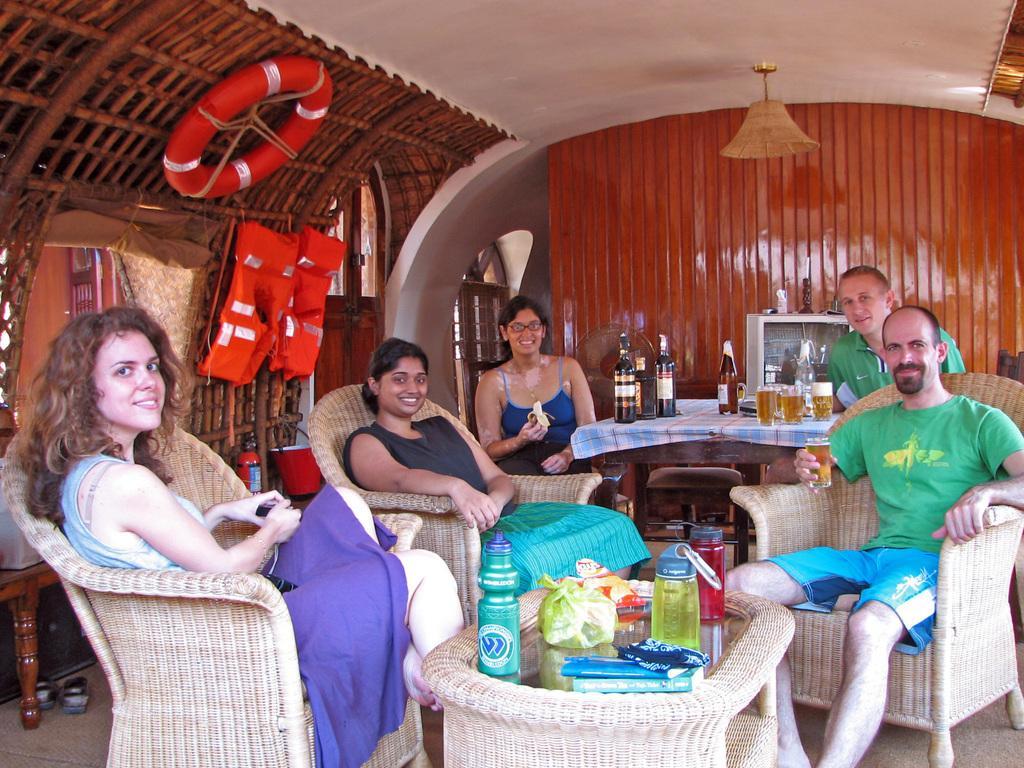Describe this image in one or two sentences. In this image there are a group of people sitting on chairs, and at the bottom of the image there is one table. On the table there are some bottles and some plastic covers, and in the background there is another table. On the table there are some bottles, glasses and there is one television. On the television there are some toys, and at the top there is ceiling and one light and on the left side there are jackets and air balloon and some objects. And in the background there is a window and wooden wall, at the bottom of a left corner there are a pair of shoes. 